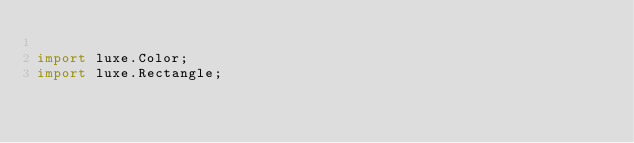Convert code to text. <code><loc_0><loc_0><loc_500><loc_500><_Haxe_>
import luxe.Color;
import luxe.Rectangle;</code> 